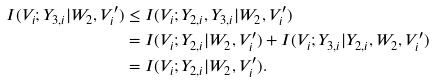<formula> <loc_0><loc_0><loc_500><loc_500>I ( V _ { i } ; Y _ { 3 , i } | W _ { 2 } , V ^ { \prime } _ { i } ) & \leq I ( V _ { i } ; Y _ { 2 , i } , Y _ { 3 , i } | W _ { 2 } , V ^ { \prime } _ { i } ) \\ & = I ( V _ { i } ; Y _ { 2 , i } | W _ { 2 } , V ^ { \prime } _ { i } ) + I ( V _ { i } ; Y _ { 3 , i } | Y _ { 2 , i } , W _ { 2 } , V ^ { \prime } _ { i } ) \\ & = I ( V _ { i } ; Y _ { 2 , i } | W _ { 2 } , V ^ { \prime } _ { i } ) .</formula> 